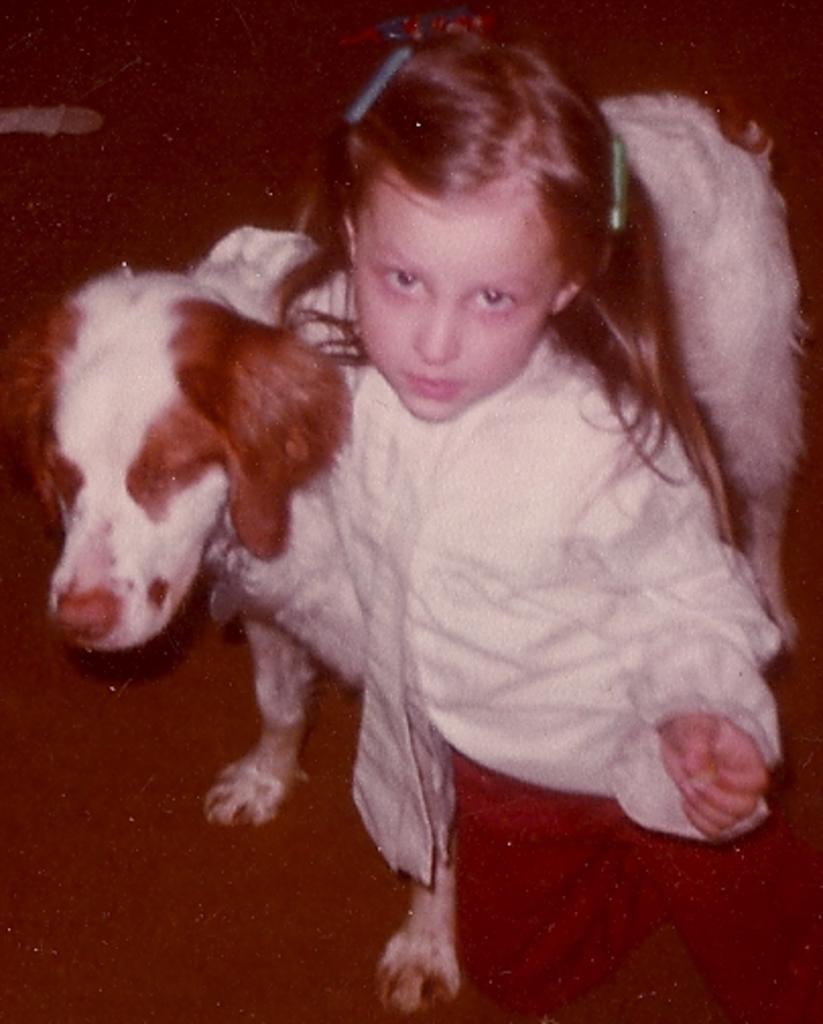Who is the main subject in the image? There is a girl in the image. What is the girl doing in the image? The girl is sitting on her knees. Are there any animals present in the image? Yes, there is a dog in the image. What type of wine is the girl drinking in the image? There is no wine present in the image; the girl is not holding or drinking any wine. 